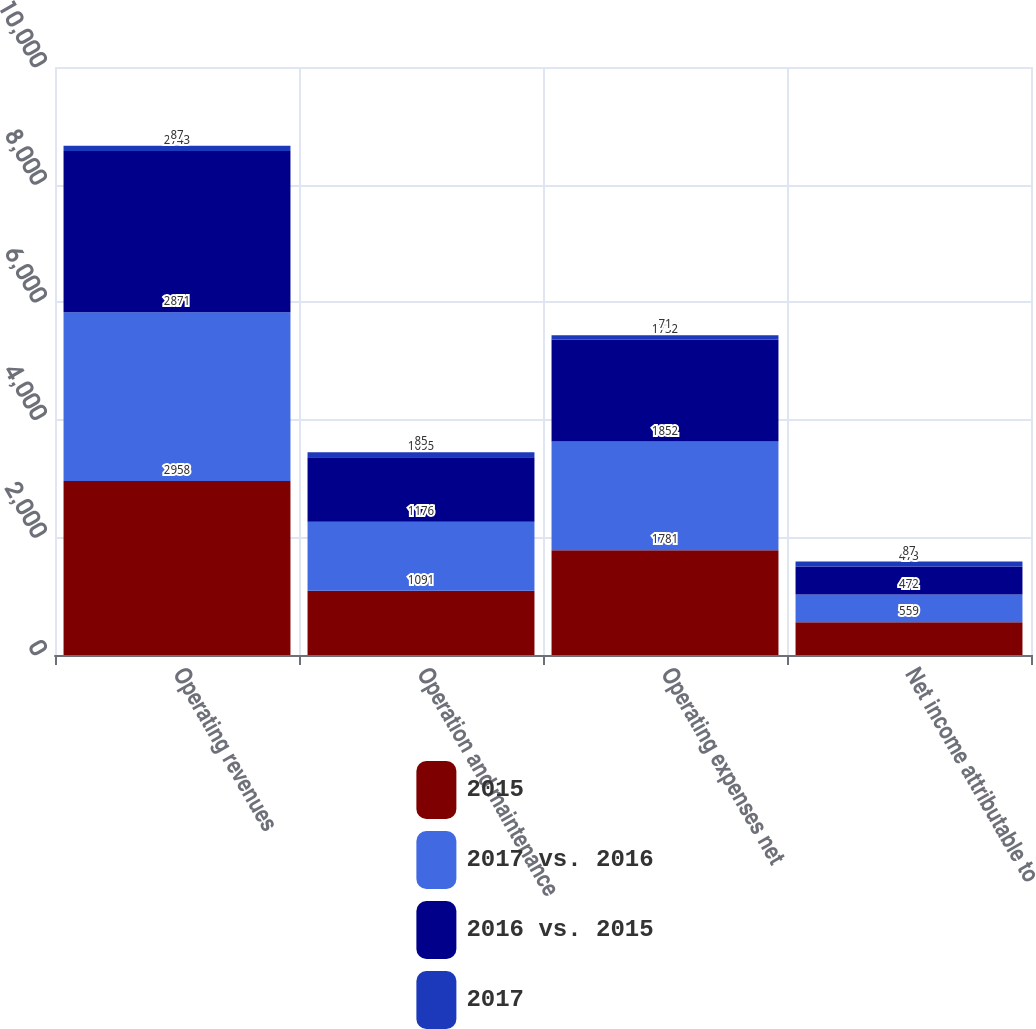Convert chart. <chart><loc_0><loc_0><loc_500><loc_500><stacked_bar_chart><ecel><fcel>Operating revenues<fcel>Operation and maintenance<fcel>Operating expenses net<fcel>Net income attributable to<nl><fcel>2015<fcel>2958<fcel>1091<fcel>1781<fcel>559<nl><fcel>2017 vs. 2016<fcel>2871<fcel>1176<fcel>1852<fcel>472<nl><fcel>2016 vs. 2015<fcel>2743<fcel>1095<fcel>1732<fcel>473<nl><fcel>2017<fcel>87<fcel>85<fcel>71<fcel>87<nl></chart> 